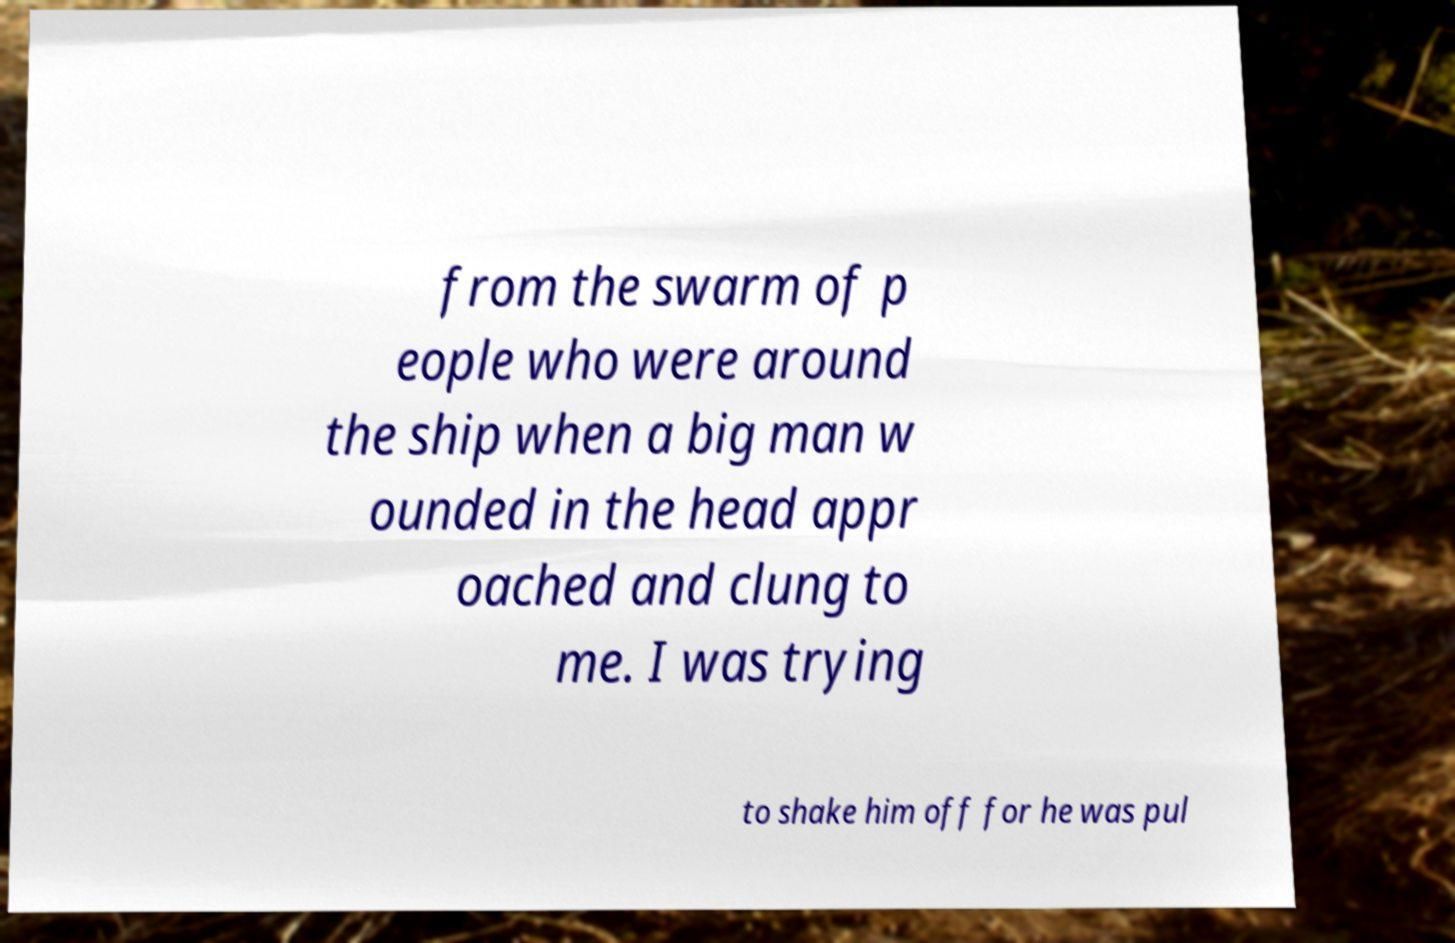Could you extract and type out the text from this image? from the swarm of p eople who were around the ship when a big man w ounded in the head appr oached and clung to me. I was trying to shake him off for he was pul 